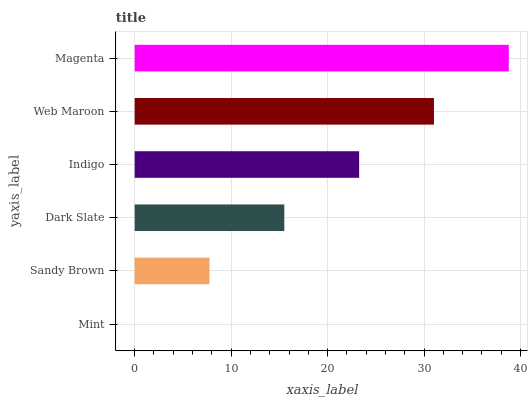Is Mint the minimum?
Answer yes or no. Yes. Is Magenta the maximum?
Answer yes or no. Yes. Is Sandy Brown the minimum?
Answer yes or no. No. Is Sandy Brown the maximum?
Answer yes or no. No. Is Sandy Brown greater than Mint?
Answer yes or no. Yes. Is Mint less than Sandy Brown?
Answer yes or no. Yes. Is Mint greater than Sandy Brown?
Answer yes or no. No. Is Sandy Brown less than Mint?
Answer yes or no. No. Is Indigo the high median?
Answer yes or no. Yes. Is Dark Slate the low median?
Answer yes or no. Yes. Is Dark Slate the high median?
Answer yes or no. No. Is Web Maroon the low median?
Answer yes or no. No. 